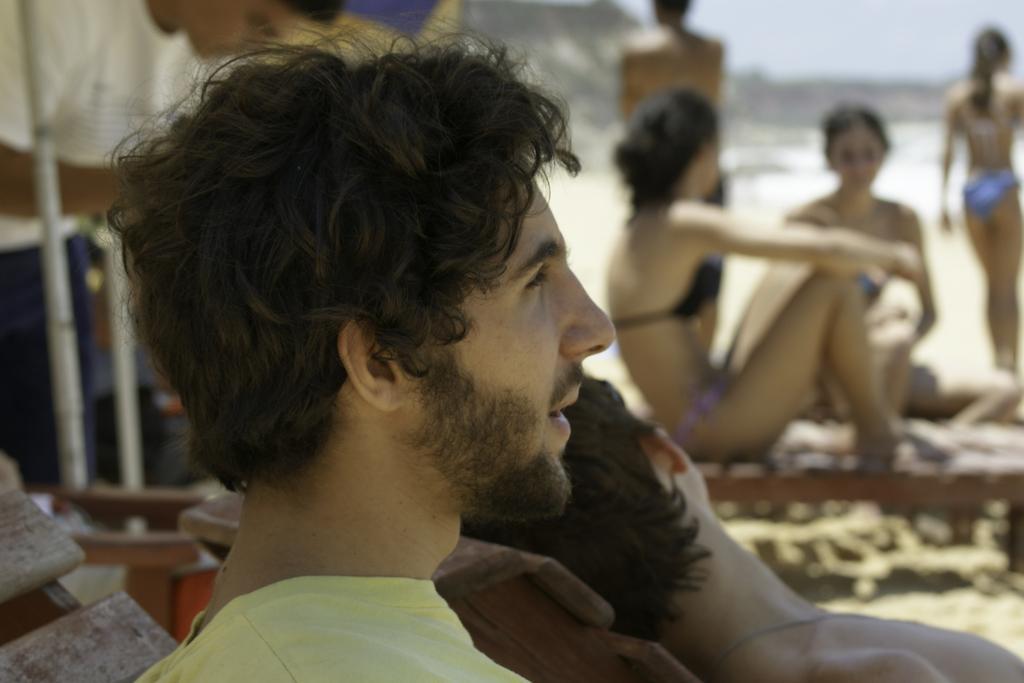In one or two sentences, can you explain what this image depicts? In this picture, we see a man in yellow T-shirt is sitting. Beside him, we see two women sitting and behind them, there are two people standing. This picture might be clicked at the beach. In the background, it is blurred. 